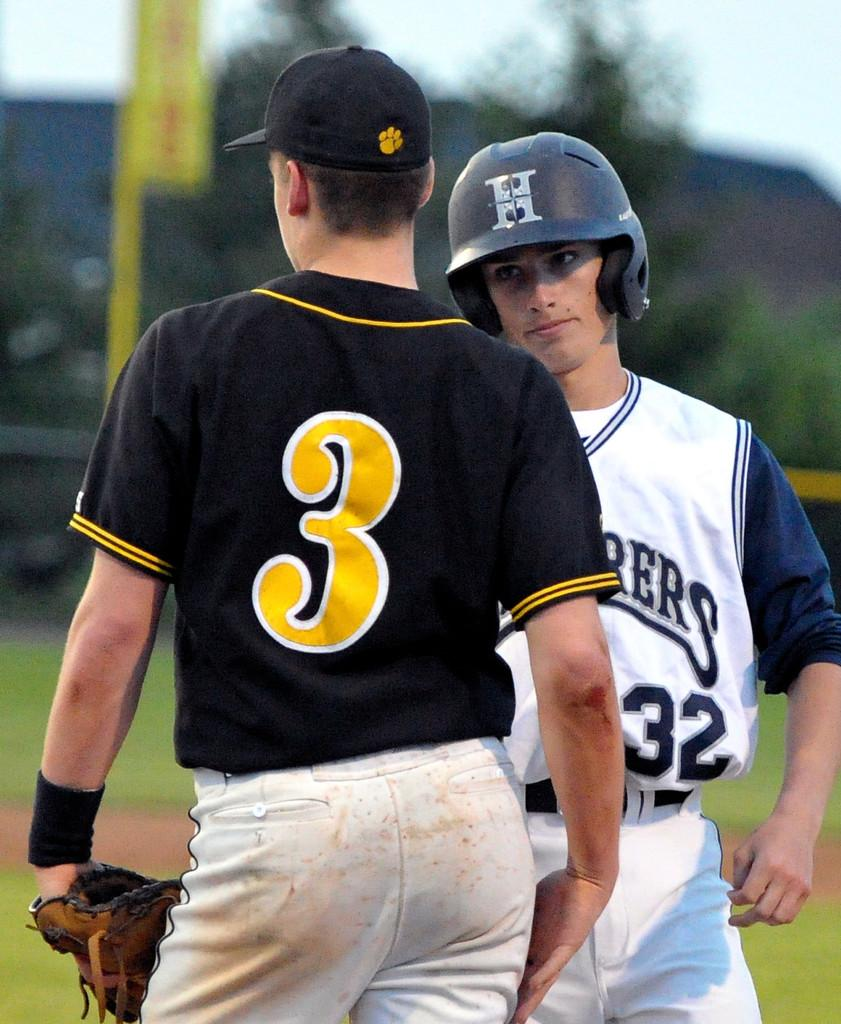How many people are in the image? There are two men standing in the image. What is the man on the left wearing on his head? One of the men is wearing a helmet. Can you describe the background of the image? The background of the image is blurry, and there is grass, trees, and the sky visible. What type of plate is being used by the man on the right in the image? There is no plate visible in the image, as both men are standing without any objects in their hands. 